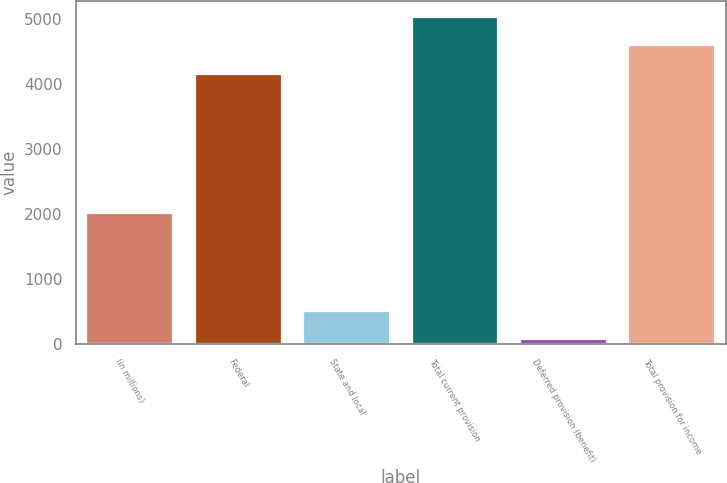Convert chart. <chart><loc_0><loc_0><loc_500><loc_500><bar_chart><fcel>(in millions)<fcel>Federal<fcel>State and local<fcel>Total current provision<fcel>Deferred provision (benefit)<fcel>Total provision for income<nl><fcel>2015<fcel>4155<fcel>509.3<fcel>5027.6<fcel>73<fcel>4591.3<nl></chart> 